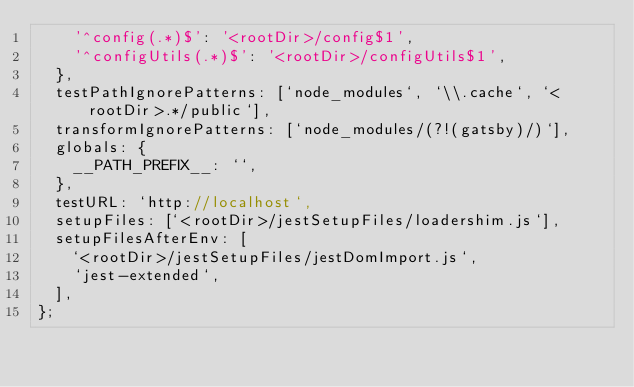Convert code to text. <code><loc_0><loc_0><loc_500><loc_500><_JavaScript_>    '^config(.*)$': '<rootDir>/config$1',
    '^configUtils(.*)$': '<rootDir>/configUtils$1',
  },
  testPathIgnorePatterns: [`node_modules`, `\\.cache`, `<rootDir>.*/public`],
  transformIgnorePatterns: [`node_modules/(?!(gatsby)/)`],
  globals: {
    __PATH_PREFIX__: ``,
  },
  testURL: `http://localhost`,
  setupFiles: [`<rootDir>/jestSetupFiles/loadershim.js`],
  setupFilesAfterEnv: [
    `<rootDir>/jestSetupFiles/jestDomImport.js`,
    `jest-extended`,
  ],
};
</code> 